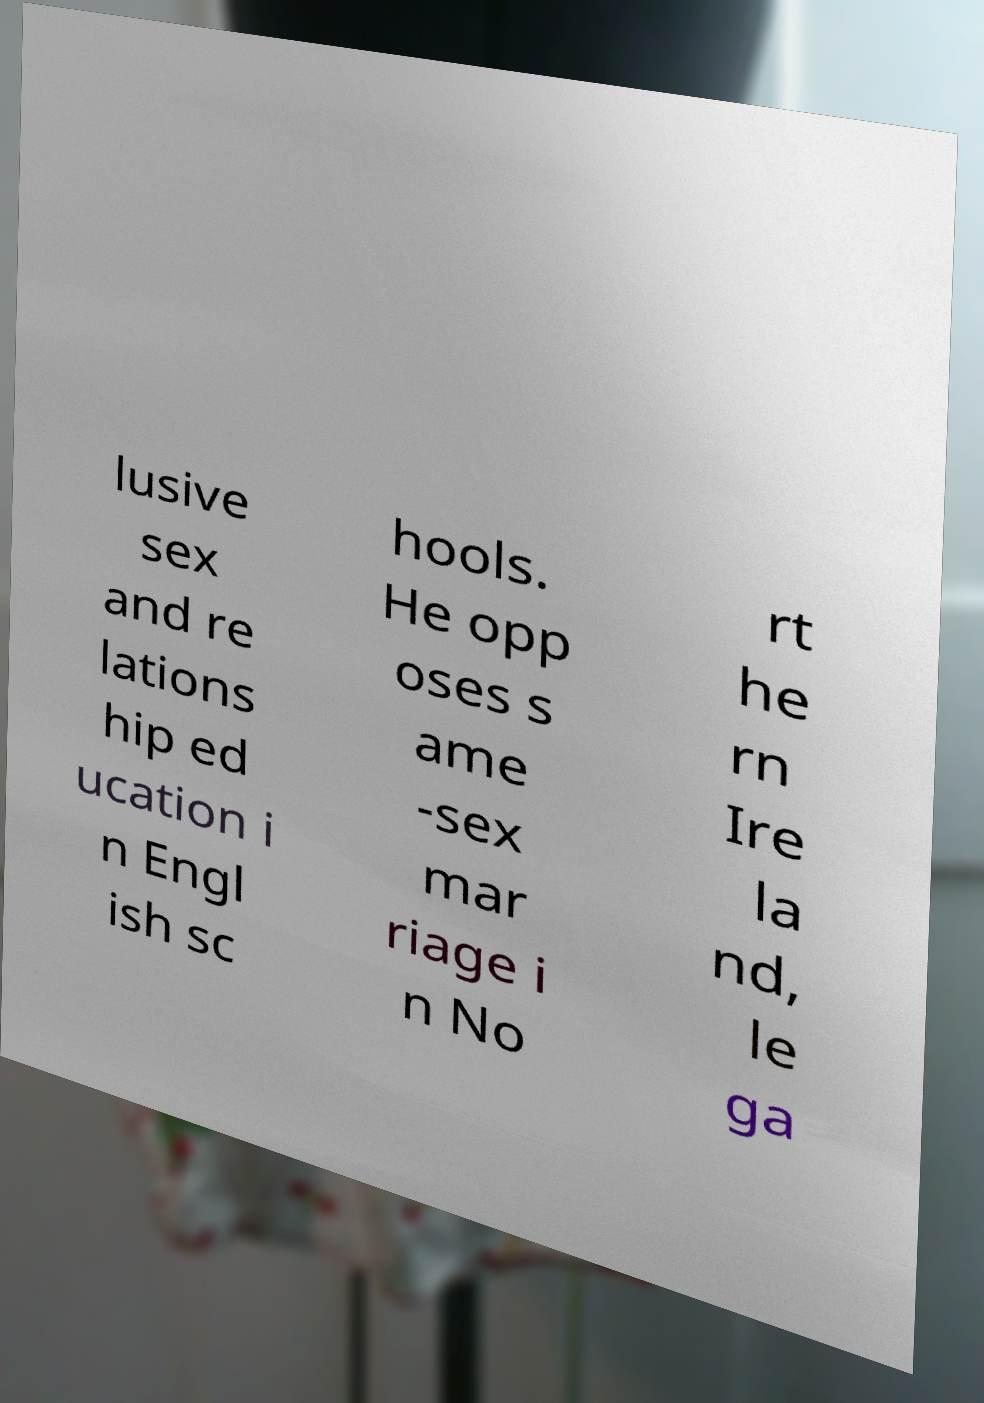Could you extract and type out the text from this image? lusive sex and re lations hip ed ucation i n Engl ish sc hools. He opp oses s ame -sex mar riage i n No rt he rn Ire la nd, le ga 